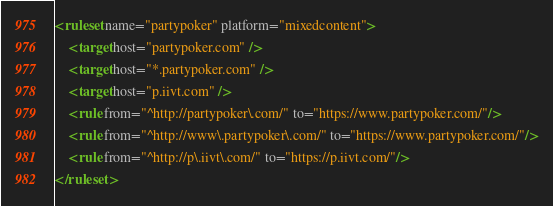Convert code to text. <code><loc_0><loc_0><loc_500><loc_500><_XML_><ruleset name="partypoker" platform="mixedcontent">
	<target host="partypoker.com" />
	<target host="*.partypoker.com" />
	<target host="p.iivt.com" />
	<rule from="^http://partypoker\.com/" to="https://www.partypoker.com/"/>
	<rule from="^http://www\.partypoker\.com/" to="https://www.partypoker.com/"/>
	<rule from="^http://p\.iivt\.com/" to="https://p.iivt.com/"/>
</ruleset>

</code> 